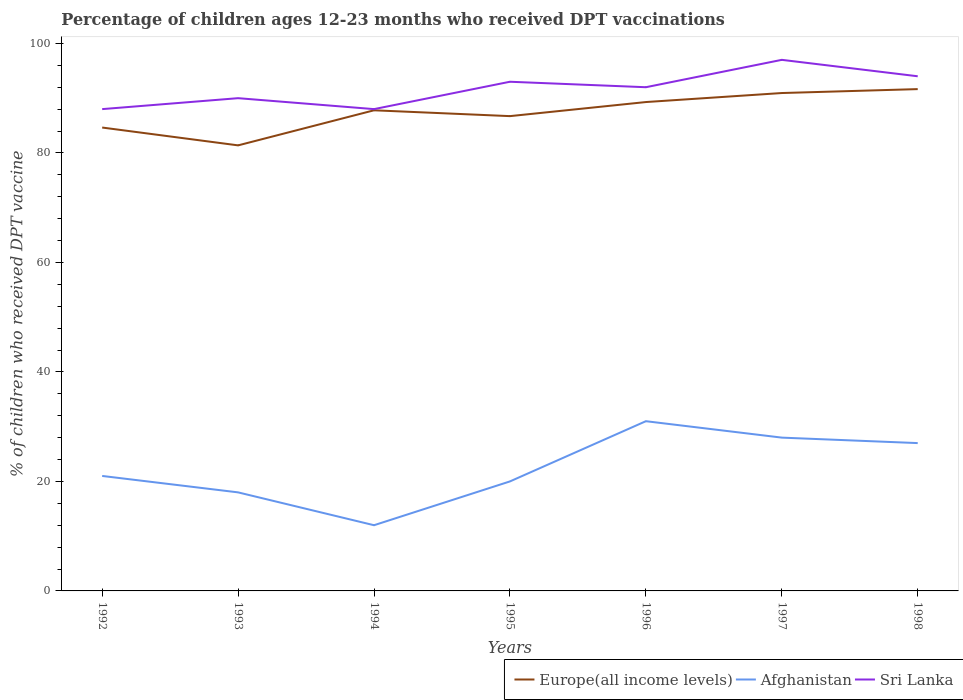How many different coloured lines are there?
Your response must be concise. 3. Across all years, what is the maximum percentage of children who received DPT vaccination in Europe(all income levels)?
Offer a very short reply. 81.38. In which year was the percentage of children who received DPT vaccination in Afghanistan maximum?
Make the answer very short. 1994. What is the total percentage of children who received DPT vaccination in Afghanistan in the graph?
Ensure brevity in your answer.  9. What is the difference between the highest and the second highest percentage of children who received DPT vaccination in Europe(all income levels)?
Offer a terse response. 10.28. What is the difference between the highest and the lowest percentage of children who received DPT vaccination in Sri Lanka?
Your answer should be very brief. 4. How many lines are there?
Provide a short and direct response. 3. Where does the legend appear in the graph?
Your answer should be very brief. Bottom right. How are the legend labels stacked?
Offer a very short reply. Horizontal. What is the title of the graph?
Provide a succinct answer. Percentage of children ages 12-23 months who received DPT vaccinations. What is the label or title of the X-axis?
Provide a succinct answer. Years. What is the label or title of the Y-axis?
Ensure brevity in your answer.  % of children who received DPT vaccine. What is the % of children who received DPT vaccine in Europe(all income levels) in 1992?
Your response must be concise. 84.64. What is the % of children who received DPT vaccine in Europe(all income levels) in 1993?
Your response must be concise. 81.38. What is the % of children who received DPT vaccine of Europe(all income levels) in 1994?
Your answer should be compact. 87.78. What is the % of children who received DPT vaccine of Europe(all income levels) in 1995?
Keep it short and to the point. 86.72. What is the % of children who received DPT vaccine in Afghanistan in 1995?
Your response must be concise. 20. What is the % of children who received DPT vaccine of Sri Lanka in 1995?
Make the answer very short. 93. What is the % of children who received DPT vaccine of Europe(all income levels) in 1996?
Provide a short and direct response. 89.29. What is the % of children who received DPT vaccine of Sri Lanka in 1996?
Your response must be concise. 92. What is the % of children who received DPT vaccine of Europe(all income levels) in 1997?
Your response must be concise. 90.94. What is the % of children who received DPT vaccine in Sri Lanka in 1997?
Provide a succinct answer. 97. What is the % of children who received DPT vaccine of Europe(all income levels) in 1998?
Provide a short and direct response. 91.65. What is the % of children who received DPT vaccine of Sri Lanka in 1998?
Give a very brief answer. 94. Across all years, what is the maximum % of children who received DPT vaccine of Europe(all income levels)?
Keep it short and to the point. 91.65. Across all years, what is the maximum % of children who received DPT vaccine of Sri Lanka?
Provide a succinct answer. 97. Across all years, what is the minimum % of children who received DPT vaccine of Europe(all income levels)?
Your answer should be very brief. 81.38. What is the total % of children who received DPT vaccine of Europe(all income levels) in the graph?
Offer a very short reply. 612.4. What is the total % of children who received DPT vaccine in Afghanistan in the graph?
Your answer should be compact. 157. What is the total % of children who received DPT vaccine in Sri Lanka in the graph?
Ensure brevity in your answer.  642. What is the difference between the % of children who received DPT vaccine of Europe(all income levels) in 1992 and that in 1993?
Keep it short and to the point. 3.26. What is the difference between the % of children who received DPT vaccine in Afghanistan in 1992 and that in 1993?
Your response must be concise. 3. What is the difference between the % of children who received DPT vaccine in Europe(all income levels) in 1992 and that in 1994?
Your response must be concise. -3.15. What is the difference between the % of children who received DPT vaccine in Afghanistan in 1992 and that in 1994?
Your answer should be compact. 9. What is the difference between the % of children who received DPT vaccine of Europe(all income levels) in 1992 and that in 1995?
Ensure brevity in your answer.  -2.08. What is the difference between the % of children who received DPT vaccine of Afghanistan in 1992 and that in 1995?
Offer a very short reply. 1. What is the difference between the % of children who received DPT vaccine in Sri Lanka in 1992 and that in 1995?
Your response must be concise. -5. What is the difference between the % of children who received DPT vaccine in Europe(all income levels) in 1992 and that in 1996?
Offer a terse response. -4.65. What is the difference between the % of children who received DPT vaccine of Afghanistan in 1992 and that in 1996?
Provide a short and direct response. -10. What is the difference between the % of children who received DPT vaccine in Sri Lanka in 1992 and that in 1996?
Make the answer very short. -4. What is the difference between the % of children who received DPT vaccine of Europe(all income levels) in 1992 and that in 1997?
Ensure brevity in your answer.  -6.3. What is the difference between the % of children who received DPT vaccine of Afghanistan in 1992 and that in 1997?
Your response must be concise. -7. What is the difference between the % of children who received DPT vaccine in Europe(all income levels) in 1992 and that in 1998?
Your response must be concise. -7.02. What is the difference between the % of children who received DPT vaccine in Sri Lanka in 1992 and that in 1998?
Your answer should be very brief. -6. What is the difference between the % of children who received DPT vaccine in Europe(all income levels) in 1993 and that in 1994?
Offer a very short reply. -6.41. What is the difference between the % of children who received DPT vaccine of Sri Lanka in 1993 and that in 1994?
Give a very brief answer. 2. What is the difference between the % of children who received DPT vaccine of Europe(all income levels) in 1993 and that in 1995?
Ensure brevity in your answer.  -5.34. What is the difference between the % of children who received DPT vaccine in Afghanistan in 1993 and that in 1995?
Offer a terse response. -2. What is the difference between the % of children who received DPT vaccine of Sri Lanka in 1993 and that in 1995?
Ensure brevity in your answer.  -3. What is the difference between the % of children who received DPT vaccine in Europe(all income levels) in 1993 and that in 1996?
Provide a succinct answer. -7.91. What is the difference between the % of children who received DPT vaccine of Afghanistan in 1993 and that in 1996?
Your answer should be compact. -13. What is the difference between the % of children who received DPT vaccine in Sri Lanka in 1993 and that in 1996?
Ensure brevity in your answer.  -2. What is the difference between the % of children who received DPT vaccine in Europe(all income levels) in 1993 and that in 1997?
Offer a terse response. -9.56. What is the difference between the % of children who received DPT vaccine of Europe(all income levels) in 1993 and that in 1998?
Make the answer very short. -10.28. What is the difference between the % of children who received DPT vaccine of Afghanistan in 1993 and that in 1998?
Provide a succinct answer. -9. What is the difference between the % of children who received DPT vaccine of Sri Lanka in 1993 and that in 1998?
Keep it short and to the point. -4. What is the difference between the % of children who received DPT vaccine of Europe(all income levels) in 1994 and that in 1995?
Provide a succinct answer. 1.06. What is the difference between the % of children who received DPT vaccine in Sri Lanka in 1994 and that in 1995?
Keep it short and to the point. -5. What is the difference between the % of children who received DPT vaccine of Europe(all income levels) in 1994 and that in 1996?
Keep it short and to the point. -1.51. What is the difference between the % of children who received DPT vaccine of Sri Lanka in 1994 and that in 1996?
Make the answer very short. -4. What is the difference between the % of children who received DPT vaccine in Europe(all income levels) in 1994 and that in 1997?
Keep it short and to the point. -3.15. What is the difference between the % of children who received DPT vaccine of Afghanistan in 1994 and that in 1997?
Provide a succinct answer. -16. What is the difference between the % of children who received DPT vaccine in Sri Lanka in 1994 and that in 1997?
Offer a terse response. -9. What is the difference between the % of children who received DPT vaccine of Europe(all income levels) in 1994 and that in 1998?
Provide a succinct answer. -3.87. What is the difference between the % of children who received DPT vaccine of Europe(all income levels) in 1995 and that in 1996?
Ensure brevity in your answer.  -2.57. What is the difference between the % of children who received DPT vaccine of Afghanistan in 1995 and that in 1996?
Ensure brevity in your answer.  -11. What is the difference between the % of children who received DPT vaccine in Europe(all income levels) in 1995 and that in 1997?
Provide a succinct answer. -4.22. What is the difference between the % of children who received DPT vaccine of Afghanistan in 1995 and that in 1997?
Your response must be concise. -8. What is the difference between the % of children who received DPT vaccine in Sri Lanka in 1995 and that in 1997?
Provide a succinct answer. -4. What is the difference between the % of children who received DPT vaccine in Europe(all income levels) in 1995 and that in 1998?
Your answer should be compact. -4.93. What is the difference between the % of children who received DPT vaccine in Afghanistan in 1995 and that in 1998?
Your answer should be very brief. -7. What is the difference between the % of children who received DPT vaccine of Europe(all income levels) in 1996 and that in 1997?
Offer a very short reply. -1.65. What is the difference between the % of children who received DPT vaccine in Europe(all income levels) in 1996 and that in 1998?
Provide a short and direct response. -2.36. What is the difference between the % of children who received DPT vaccine in Europe(all income levels) in 1997 and that in 1998?
Your answer should be very brief. -0.72. What is the difference between the % of children who received DPT vaccine in Afghanistan in 1997 and that in 1998?
Make the answer very short. 1. What is the difference between the % of children who received DPT vaccine in Europe(all income levels) in 1992 and the % of children who received DPT vaccine in Afghanistan in 1993?
Your response must be concise. 66.64. What is the difference between the % of children who received DPT vaccine in Europe(all income levels) in 1992 and the % of children who received DPT vaccine in Sri Lanka in 1993?
Provide a succinct answer. -5.36. What is the difference between the % of children who received DPT vaccine of Afghanistan in 1992 and the % of children who received DPT vaccine of Sri Lanka in 1993?
Make the answer very short. -69. What is the difference between the % of children who received DPT vaccine in Europe(all income levels) in 1992 and the % of children who received DPT vaccine in Afghanistan in 1994?
Your response must be concise. 72.64. What is the difference between the % of children who received DPT vaccine of Europe(all income levels) in 1992 and the % of children who received DPT vaccine of Sri Lanka in 1994?
Provide a succinct answer. -3.36. What is the difference between the % of children who received DPT vaccine of Afghanistan in 1992 and the % of children who received DPT vaccine of Sri Lanka in 1994?
Ensure brevity in your answer.  -67. What is the difference between the % of children who received DPT vaccine in Europe(all income levels) in 1992 and the % of children who received DPT vaccine in Afghanistan in 1995?
Your response must be concise. 64.64. What is the difference between the % of children who received DPT vaccine of Europe(all income levels) in 1992 and the % of children who received DPT vaccine of Sri Lanka in 1995?
Your answer should be very brief. -8.36. What is the difference between the % of children who received DPT vaccine of Afghanistan in 1992 and the % of children who received DPT vaccine of Sri Lanka in 1995?
Provide a short and direct response. -72. What is the difference between the % of children who received DPT vaccine of Europe(all income levels) in 1992 and the % of children who received DPT vaccine of Afghanistan in 1996?
Your response must be concise. 53.64. What is the difference between the % of children who received DPT vaccine in Europe(all income levels) in 1992 and the % of children who received DPT vaccine in Sri Lanka in 1996?
Your answer should be very brief. -7.36. What is the difference between the % of children who received DPT vaccine in Afghanistan in 1992 and the % of children who received DPT vaccine in Sri Lanka in 1996?
Keep it short and to the point. -71. What is the difference between the % of children who received DPT vaccine of Europe(all income levels) in 1992 and the % of children who received DPT vaccine of Afghanistan in 1997?
Offer a terse response. 56.64. What is the difference between the % of children who received DPT vaccine of Europe(all income levels) in 1992 and the % of children who received DPT vaccine of Sri Lanka in 1997?
Ensure brevity in your answer.  -12.36. What is the difference between the % of children who received DPT vaccine of Afghanistan in 1992 and the % of children who received DPT vaccine of Sri Lanka in 1997?
Provide a short and direct response. -76. What is the difference between the % of children who received DPT vaccine in Europe(all income levels) in 1992 and the % of children who received DPT vaccine in Afghanistan in 1998?
Your answer should be very brief. 57.64. What is the difference between the % of children who received DPT vaccine of Europe(all income levels) in 1992 and the % of children who received DPT vaccine of Sri Lanka in 1998?
Offer a terse response. -9.36. What is the difference between the % of children who received DPT vaccine of Afghanistan in 1992 and the % of children who received DPT vaccine of Sri Lanka in 1998?
Provide a short and direct response. -73. What is the difference between the % of children who received DPT vaccine in Europe(all income levels) in 1993 and the % of children who received DPT vaccine in Afghanistan in 1994?
Ensure brevity in your answer.  69.38. What is the difference between the % of children who received DPT vaccine of Europe(all income levels) in 1993 and the % of children who received DPT vaccine of Sri Lanka in 1994?
Provide a short and direct response. -6.62. What is the difference between the % of children who received DPT vaccine in Afghanistan in 1993 and the % of children who received DPT vaccine in Sri Lanka in 1994?
Your response must be concise. -70. What is the difference between the % of children who received DPT vaccine in Europe(all income levels) in 1993 and the % of children who received DPT vaccine in Afghanistan in 1995?
Provide a succinct answer. 61.38. What is the difference between the % of children who received DPT vaccine of Europe(all income levels) in 1993 and the % of children who received DPT vaccine of Sri Lanka in 1995?
Make the answer very short. -11.62. What is the difference between the % of children who received DPT vaccine in Afghanistan in 1993 and the % of children who received DPT vaccine in Sri Lanka in 1995?
Your response must be concise. -75. What is the difference between the % of children who received DPT vaccine of Europe(all income levels) in 1993 and the % of children who received DPT vaccine of Afghanistan in 1996?
Give a very brief answer. 50.38. What is the difference between the % of children who received DPT vaccine of Europe(all income levels) in 1993 and the % of children who received DPT vaccine of Sri Lanka in 1996?
Keep it short and to the point. -10.62. What is the difference between the % of children who received DPT vaccine in Afghanistan in 1993 and the % of children who received DPT vaccine in Sri Lanka in 1996?
Keep it short and to the point. -74. What is the difference between the % of children who received DPT vaccine in Europe(all income levels) in 1993 and the % of children who received DPT vaccine in Afghanistan in 1997?
Ensure brevity in your answer.  53.38. What is the difference between the % of children who received DPT vaccine in Europe(all income levels) in 1993 and the % of children who received DPT vaccine in Sri Lanka in 1997?
Keep it short and to the point. -15.62. What is the difference between the % of children who received DPT vaccine in Afghanistan in 1993 and the % of children who received DPT vaccine in Sri Lanka in 1997?
Offer a very short reply. -79. What is the difference between the % of children who received DPT vaccine in Europe(all income levels) in 1993 and the % of children who received DPT vaccine in Afghanistan in 1998?
Make the answer very short. 54.38. What is the difference between the % of children who received DPT vaccine in Europe(all income levels) in 1993 and the % of children who received DPT vaccine in Sri Lanka in 1998?
Keep it short and to the point. -12.62. What is the difference between the % of children who received DPT vaccine of Afghanistan in 1993 and the % of children who received DPT vaccine of Sri Lanka in 1998?
Offer a terse response. -76. What is the difference between the % of children who received DPT vaccine of Europe(all income levels) in 1994 and the % of children who received DPT vaccine of Afghanistan in 1995?
Offer a very short reply. 67.78. What is the difference between the % of children who received DPT vaccine in Europe(all income levels) in 1994 and the % of children who received DPT vaccine in Sri Lanka in 1995?
Provide a short and direct response. -5.22. What is the difference between the % of children who received DPT vaccine in Afghanistan in 1994 and the % of children who received DPT vaccine in Sri Lanka in 1995?
Your answer should be very brief. -81. What is the difference between the % of children who received DPT vaccine in Europe(all income levels) in 1994 and the % of children who received DPT vaccine in Afghanistan in 1996?
Your response must be concise. 56.78. What is the difference between the % of children who received DPT vaccine in Europe(all income levels) in 1994 and the % of children who received DPT vaccine in Sri Lanka in 1996?
Provide a short and direct response. -4.22. What is the difference between the % of children who received DPT vaccine of Afghanistan in 1994 and the % of children who received DPT vaccine of Sri Lanka in 1996?
Provide a succinct answer. -80. What is the difference between the % of children who received DPT vaccine of Europe(all income levels) in 1994 and the % of children who received DPT vaccine of Afghanistan in 1997?
Make the answer very short. 59.78. What is the difference between the % of children who received DPT vaccine of Europe(all income levels) in 1994 and the % of children who received DPT vaccine of Sri Lanka in 1997?
Your answer should be very brief. -9.22. What is the difference between the % of children who received DPT vaccine of Afghanistan in 1994 and the % of children who received DPT vaccine of Sri Lanka in 1997?
Your response must be concise. -85. What is the difference between the % of children who received DPT vaccine of Europe(all income levels) in 1994 and the % of children who received DPT vaccine of Afghanistan in 1998?
Keep it short and to the point. 60.78. What is the difference between the % of children who received DPT vaccine in Europe(all income levels) in 1994 and the % of children who received DPT vaccine in Sri Lanka in 1998?
Ensure brevity in your answer.  -6.22. What is the difference between the % of children who received DPT vaccine in Afghanistan in 1994 and the % of children who received DPT vaccine in Sri Lanka in 1998?
Your answer should be very brief. -82. What is the difference between the % of children who received DPT vaccine in Europe(all income levels) in 1995 and the % of children who received DPT vaccine in Afghanistan in 1996?
Keep it short and to the point. 55.72. What is the difference between the % of children who received DPT vaccine in Europe(all income levels) in 1995 and the % of children who received DPT vaccine in Sri Lanka in 1996?
Make the answer very short. -5.28. What is the difference between the % of children who received DPT vaccine in Afghanistan in 1995 and the % of children who received DPT vaccine in Sri Lanka in 1996?
Offer a terse response. -72. What is the difference between the % of children who received DPT vaccine of Europe(all income levels) in 1995 and the % of children who received DPT vaccine of Afghanistan in 1997?
Provide a succinct answer. 58.72. What is the difference between the % of children who received DPT vaccine of Europe(all income levels) in 1995 and the % of children who received DPT vaccine of Sri Lanka in 1997?
Provide a succinct answer. -10.28. What is the difference between the % of children who received DPT vaccine of Afghanistan in 1995 and the % of children who received DPT vaccine of Sri Lanka in 1997?
Your answer should be compact. -77. What is the difference between the % of children who received DPT vaccine of Europe(all income levels) in 1995 and the % of children who received DPT vaccine of Afghanistan in 1998?
Keep it short and to the point. 59.72. What is the difference between the % of children who received DPT vaccine of Europe(all income levels) in 1995 and the % of children who received DPT vaccine of Sri Lanka in 1998?
Offer a very short reply. -7.28. What is the difference between the % of children who received DPT vaccine of Afghanistan in 1995 and the % of children who received DPT vaccine of Sri Lanka in 1998?
Give a very brief answer. -74. What is the difference between the % of children who received DPT vaccine of Europe(all income levels) in 1996 and the % of children who received DPT vaccine of Afghanistan in 1997?
Provide a short and direct response. 61.29. What is the difference between the % of children who received DPT vaccine in Europe(all income levels) in 1996 and the % of children who received DPT vaccine in Sri Lanka in 1997?
Your response must be concise. -7.71. What is the difference between the % of children who received DPT vaccine in Afghanistan in 1996 and the % of children who received DPT vaccine in Sri Lanka in 1997?
Make the answer very short. -66. What is the difference between the % of children who received DPT vaccine of Europe(all income levels) in 1996 and the % of children who received DPT vaccine of Afghanistan in 1998?
Provide a succinct answer. 62.29. What is the difference between the % of children who received DPT vaccine of Europe(all income levels) in 1996 and the % of children who received DPT vaccine of Sri Lanka in 1998?
Provide a succinct answer. -4.71. What is the difference between the % of children who received DPT vaccine in Afghanistan in 1996 and the % of children who received DPT vaccine in Sri Lanka in 1998?
Provide a short and direct response. -63. What is the difference between the % of children who received DPT vaccine in Europe(all income levels) in 1997 and the % of children who received DPT vaccine in Afghanistan in 1998?
Your response must be concise. 63.94. What is the difference between the % of children who received DPT vaccine in Europe(all income levels) in 1997 and the % of children who received DPT vaccine in Sri Lanka in 1998?
Make the answer very short. -3.06. What is the difference between the % of children who received DPT vaccine in Afghanistan in 1997 and the % of children who received DPT vaccine in Sri Lanka in 1998?
Your answer should be very brief. -66. What is the average % of children who received DPT vaccine of Europe(all income levels) per year?
Offer a very short reply. 87.49. What is the average % of children who received DPT vaccine of Afghanistan per year?
Keep it short and to the point. 22.43. What is the average % of children who received DPT vaccine in Sri Lanka per year?
Give a very brief answer. 91.71. In the year 1992, what is the difference between the % of children who received DPT vaccine in Europe(all income levels) and % of children who received DPT vaccine in Afghanistan?
Offer a terse response. 63.64. In the year 1992, what is the difference between the % of children who received DPT vaccine of Europe(all income levels) and % of children who received DPT vaccine of Sri Lanka?
Your answer should be compact. -3.36. In the year 1992, what is the difference between the % of children who received DPT vaccine of Afghanistan and % of children who received DPT vaccine of Sri Lanka?
Provide a short and direct response. -67. In the year 1993, what is the difference between the % of children who received DPT vaccine in Europe(all income levels) and % of children who received DPT vaccine in Afghanistan?
Your answer should be compact. 63.38. In the year 1993, what is the difference between the % of children who received DPT vaccine of Europe(all income levels) and % of children who received DPT vaccine of Sri Lanka?
Offer a very short reply. -8.62. In the year 1993, what is the difference between the % of children who received DPT vaccine of Afghanistan and % of children who received DPT vaccine of Sri Lanka?
Your answer should be compact. -72. In the year 1994, what is the difference between the % of children who received DPT vaccine of Europe(all income levels) and % of children who received DPT vaccine of Afghanistan?
Provide a succinct answer. 75.78. In the year 1994, what is the difference between the % of children who received DPT vaccine of Europe(all income levels) and % of children who received DPT vaccine of Sri Lanka?
Your answer should be compact. -0.22. In the year 1994, what is the difference between the % of children who received DPT vaccine of Afghanistan and % of children who received DPT vaccine of Sri Lanka?
Your response must be concise. -76. In the year 1995, what is the difference between the % of children who received DPT vaccine in Europe(all income levels) and % of children who received DPT vaccine in Afghanistan?
Your response must be concise. 66.72. In the year 1995, what is the difference between the % of children who received DPT vaccine of Europe(all income levels) and % of children who received DPT vaccine of Sri Lanka?
Your response must be concise. -6.28. In the year 1995, what is the difference between the % of children who received DPT vaccine of Afghanistan and % of children who received DPT vaccine of Sri Lanka?
Provide a succinct answer. -73. In the year 1996, what is the difference between the % of children who received DPT vaccine in Europe(all income levels) and % of children who received DPT vaccine in Afghanistan?
Ensure brevity in your answer.  58.29. In the year 1996, what is the difference between the % of children who received DPT vaccine in Europe(all income levels) and % of children who received DPT vaccine in Sri Lanka?
Your answer should be compact. -2.71. In the year 1996, what is the difference between the % of children who received DPT vaccine in Afghanistan and % of children who received DPT vaccine in Sri Lanka?
Offer a terse response. -61. In the year 1997, what is the difference between the % of children who received DPT vaccine of Europe(all income levels) and % of children who received DPT vaccine of Afghanistan?
Your answer should be very brief. 62.94. In the year 1997, what is the difference between the % of children who received DPT vaccine of Europe(all income levels) and % of children who received DPT vaccine of Sri Lanka?
Give a very brief answer. -6.06. In the year 1997, what is the difference between the % of children who received DPT vaccine in Afghanistan and % of children who received DPT vaccine in Sri Lanka?
Offer a terse response. -69. In the year 1998, what is the difference between the % of children who received DPT vaccine in Europe(all income levels) and % of children who received DPT vaccine in Afghanistan?
Make the answer very short. 64.65. In the year 1998, what is the difference between the % of children who received DPT vaccine of Europe(all income levels) and % of children who received DPT vaccine of Sri Lanka?
Give a very brief answer. -2.35. In the year 1998, what is the difference between the % of children who received DPT vaccine in Afghanistan and % of children who received DPT vaccine in Sri Lanka?
Your answer should be compact. -67. What is the ratio of the % of children who received DPT vaccine in Afghanistan in 1992 to that in 1993?
Your response must be concise. 1.17. What is the ratio of the % of children who received DPT vaccine in Sri Lanka in 1992 to that in 1993?
Offer a very short reply. 0.98. What is the ratio of the % of children who received DPT vaccine of Europe(all income levels) in 1992 to that in 1994?
Your response must be concise. 0.96. What is the ratio of the % of children who received DPT vaccine in Afghanistan in 1992 to that in 1994?
Ensure brevity in your answer.  1.75. What is the ratio of the % of children who received DPT vaccine of Sri Lanka in 1992 to that in 1994?
Your response must be concise. 1. What is the ratio of the % of children who received DPT vaccine in Europe(all income levels) in 1992 to that in 1995?
Provide a succinct answer. 0.98. What is the ratio of the % of children who received DPT vaccine in Afghanistan in 1992 to that in 1995?
Offer a terse response. 1.05. What is the ratio of the % of children who received DPT vaccine of Sri Lanka in 1992 to that in 1995?
Provide a succinct answer. 0.95. What is the ratio of the % of children who received DPT vaccine of Europe(all income levels) in 1992 to that in 1996?
Give a very brief answer. 0.95. What is the ratio of the % of children who received DPT vaccine in Afghanistan in 1992 to that in 1996?
Keep it short and to the point. 0.68. What is the ratio of the % of children who received DPT vaccine of Sri Lanka in 1992 to that in 1996?
Your response must be concise. 0.96. What is the ratio of the % of children who received DPT vaccine of Europe(all income levels) in 1992 to that in 1997?
Provide a short and direct response. 0.93. What is the ratio of the % of children who received DPT vaccine of Afghanistan in 1992 to that in 1997?
Offer a terse response. 0.75. What is the ratio of the % of children who received DPT vaccine in Sri Lanka in 1992 to that in 1997?
Keep it short and to the point. 0.91. What is the ratio of the % of children who received DPT vaccine of Europe(all income levels) in 1992 to that in 1998?
Ensure brevity in your answer.  0.92. What is the ratio of the % of children who received DPT vaccine in Sri Lanka in 1992 to that in 1998?
Ensure brevity in your answer.  0.94. What is the ratio of the % of children who received DPT vaccine of Europe(all income levels) in 1993 to that in 1994?
Your answer should be compact. 0.93. What is the ratio of the % of children who received DPT vaccine in Sri Lanka in 1993 to that in 1994?
Your answer should be compact. 1.02. What is the ratio of the % of children who received DPT vaccine of Europe(all income levels) in 1993 to that in 1995?
Ensure brevity in your answer.  0.94. What is the ratio of the % of children who received DPT vaccine of Afghanistan in 1993 to that in 1995?
Your answer should be compact. 0.9. What is the ratio of the % of children who received DPT vaccine in Sri Lanka in 1993 to that in 1995?
Keep it short and to the point. 0.97. What is the ratio of the % of children who received DPT vaccine in Europe(all income levels) in 1993 to that in 1996?
Your answer should be compact. 0.91. What is the ratio of the % of children who received DPT vaccine in Afghanistan in 1993 to that in 1996?
Ensure brevity in your answer.  0.58. What is the ratio of the % of children who received DPT vaccine in Sri Lanka in 1993 to that in 1996?
Your response must be concise. 0.98. What is the ratio of the % of children who received DPT vaccine in Europe(all income levels) in 1993 to that in 1997?
Provide a short and direct response. 0.89. What is the ratio of the % of children who received DPT vaccine in Afghanistan in 1993 to that in 1997?
Keep it short and to the point. 0.64. What is the ratio of the % of children who received DPT vaccine in Sri Lanka in 1993 to that in 1997?
Offer a terse response. 0.93. What is the ratio of the % of children who received DPT vaccine of Europe(all income levels) in 1993 to that in 1998?
Give a very brief answer. 0.89. What is the ratio of the % of children who received DPT vaccine of Sri Lanka in 1993 to that in 1998?
Provide a succinct answer. 0.96. What is the ratio of the % of children who received DPT vaccine of Europe(all income levels) in 1994 to that in 1995?
Give a very brief answer. 1.01. What is the ratio of the % of children who received DPT vaccine in Sri Lanka in 1994 to that in 1995?
Your response must be concise. 0.95. What is the ratio of the % of children who received DPT vaccine of Europe(all income levels) in 1994 to that in 1996?
Keep it short and to the point. 0.98. What is the ratio of the % of children who received DPT vaccine of Afghanistan in 1994 to that in 1996?
Your response must be concise. 0.39. What is the ratio of the % of children who received DPT vaccine in Sri Lanka in 1994 to that in 1996?
Provide a succinct answer. 0.96. What is the ratio of the % of children who received DPT vaccine in Europe(all income levels) in 1994 to that in 1997?
Make the answer very short. 0.97. What is the ratio of the % of children who received DPT vaccine of Afghanistan in 1994 to that in 1997?
Provide a succinct answer. 0.43. What is the ratio of the % of children who received DPT vaccine of Sri Lanka in 1994 to that in 1997?
Offer a terse response. 0.91. What is the ratio of the % of children who received DPT vaccine in Europe(all income levels) in 1994 to that in 1998?
Keep it short and to the point. 0.96. What is the ratio of the % of children who received DPT vaccine in Afghanistan in 1994 to that in 1998?
Your response must be concise. 0.44. What is the ratio of the % of children who received DPT vaccine of Sri Lanka in 1994 to that in 1998?
Your response must be concise. 0.94. What is the ratio of the % of children who received DPT vaccine of Europe(all income levels) in 1995 to that in 1996?
Keep it short and to the point. 0.97. What is the ratio of the % of children who received DPT vaccine of Afghanistan in 1995 to that in 1996?
Your answer should be very brief. 0.65. What is the ratio of the % of children who received DPT vaccine of Sri Lanka in 1995 to that in 1996?
Offer a terse response. 1.01. What is the ratio of the % of children who received DPT vaccine in Europe(all income levels) in 1995 to that in 1997?
Provide a succinct answer. 0.95. What is the ratio of the % of children who received DPT vaccine of Sri Lanka in 1995 to that in 1997?
Provide a short and direct response. 0.96. What is the ratio of the % of children who received DPT vaccine of Europe(all income levels) in 1995 to that in 1998?
Offer a terse response. 0.95. What is the ratio of the % of children who received DPT vaccine of Afghanistan in 1995 to that in 1998?
Ensure brevity in your answer.  0.74. What is the ratio of the % of children who received DPT vaccine of Sri Lanka in 1995 to that in 1998?
Give a very brief answer. 0.99. What is the ratio of the % of children who received DPT vaccine in Europe(all income levels) in 1996 to that in 1997?
Ensure brevity in your answer.  0.98. What is the ratio of the % of children who received DPT vaccine of Afghanistan in 1996 to that in 1997?
Keep it short and to the point. 1.11. What is the ratio of the % of children who received DPT vaccine in Sri Lanka in 1996 to that in 1997?
Keep it short and to the point. 0.95. What is the ratio of the % of children who received DPT vaccine of Europe(all income levels) in 1996 to that in 1998?
Provide a short and direct response. 0.97. What is the ratio of the % of children who received DPT vaccine in Afghanistan in 1996 to that in 1998?
Offer a very short reply. 1.15. What is the ratio of the % of children who received DPT vaccine in Sri Lanka in 1996 to that in 1998?
Keep it short and to the point. 0.98. What is the ratio of the % of children who received DPT vaccine in Sri Lanka in 1997 to that in 1998?
Provide a short and direct response. 1.03. What is the difference between the highest and the second highest % of children who received DPT vaccine in Europe(all income levels)?
Your answer should be very brief. 0.72. What is the difference between the highest and the second highest % of children who received DPT vaccine of Sri Lanka?
Ensure brevity in your answer.  3. What is the difference between the highest and the lowest % of children who received DPT vaccine in Europe(all income levels)?
Make the answer very short. 10.28. What is the difference between the highest and the lowest % of children who received DPT vaccine of Afghanistan?
Make the answer very short. 19. 